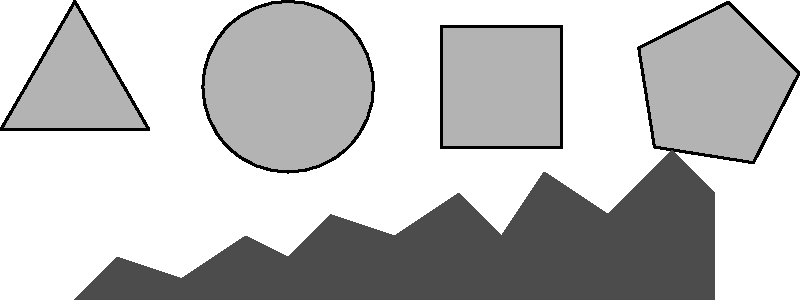Which of the given abstract shapes, when rotated appropriately, would best fit into the cityscape silhouette to represent a skyscraper with a unique architectural design? To answer this question, we need to analyze each shape and its potential to fit into the cityscape silhouette:

1. Triangle (leftmost shape):
   - When rotated 45 degrees, it forms a pointed top, which could represent a modern, angular skyscraper.
   - However, its base is too wide to fit well within the silhouette.

2. Circle (second from left):
   - A circle, regardless of rotation, maintains its shape.
   - It doesn't match the angular nature of most buildings in a cityscape.

3. Square (second from right):
   - When rotated 45 degrees, it forms a diamond shape.
   - This shape closely resembles many modern skyscrapers with tapered tops and could fit well within the silhouette.

4. Pentagon (rightmost shape):
   - When rotated, it can create an interesting profile.
   - However, its five-sided nature doesn't align as well with typical architectural designs in cityscapes.

Considering the silhouette's angular nature and the common shapes of skyscrapers, the square (rotated 45 degrees to form a diamond) would best fit into the cityscape. It can represent a tall, sleek building with a tapered top, which is a common architectural design in modern cities.

This choice also aligns with the persona of a poet finding inspiration in the city's diversity, as diamond-shaped skyscrapers often stand out as unique and inspiring elements in a city's skyline.
Answer: Square (rotated 45 degrees) 